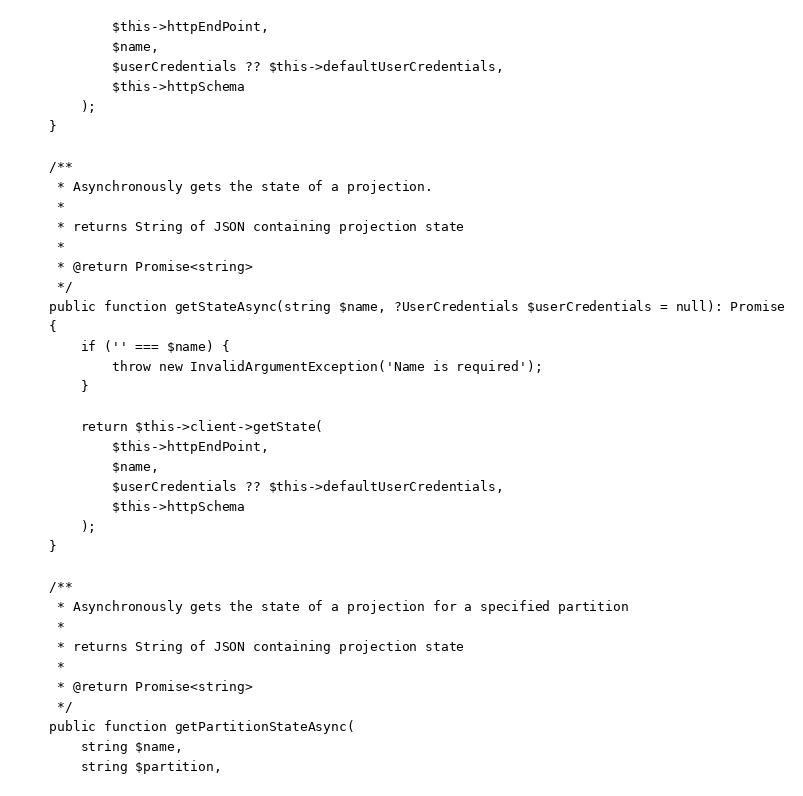<code> <loc_0><loc_0><loc_500><loc_500><_PHP_>            $this->httpEndPoint,
            $name,
            $userCredentials ?? $this->defaultUserCredentials,
            $this->httpSchema
        );
    }

    /**
     * Asynchronously gets the state of a projection.
     *
     * returns String of JSON containing projection state
     *
     * @return Promise<string>
     */
    public function getStateAsync(string $name, ?UserCredentials $userCredentials = null): Promise
    {
        if ('' === $name) {
            throw new InvalidArgumentException('Name is required');
        }

        return $this->client->getState(
            $this->httpEndPoint,
            $name,
            $userCredentials ?? $this->defaultUserCredentials,
            $this->httpSchema
        );
    }

    /**
     * Asynchronously gets the state of a projection for a specified partition
     *
     * returns String of JSON containing projection state
     *
     * @return Promise<string>
     */
    public function getPartitionStateAsync(
        string $name,
        string $partition,</code> 